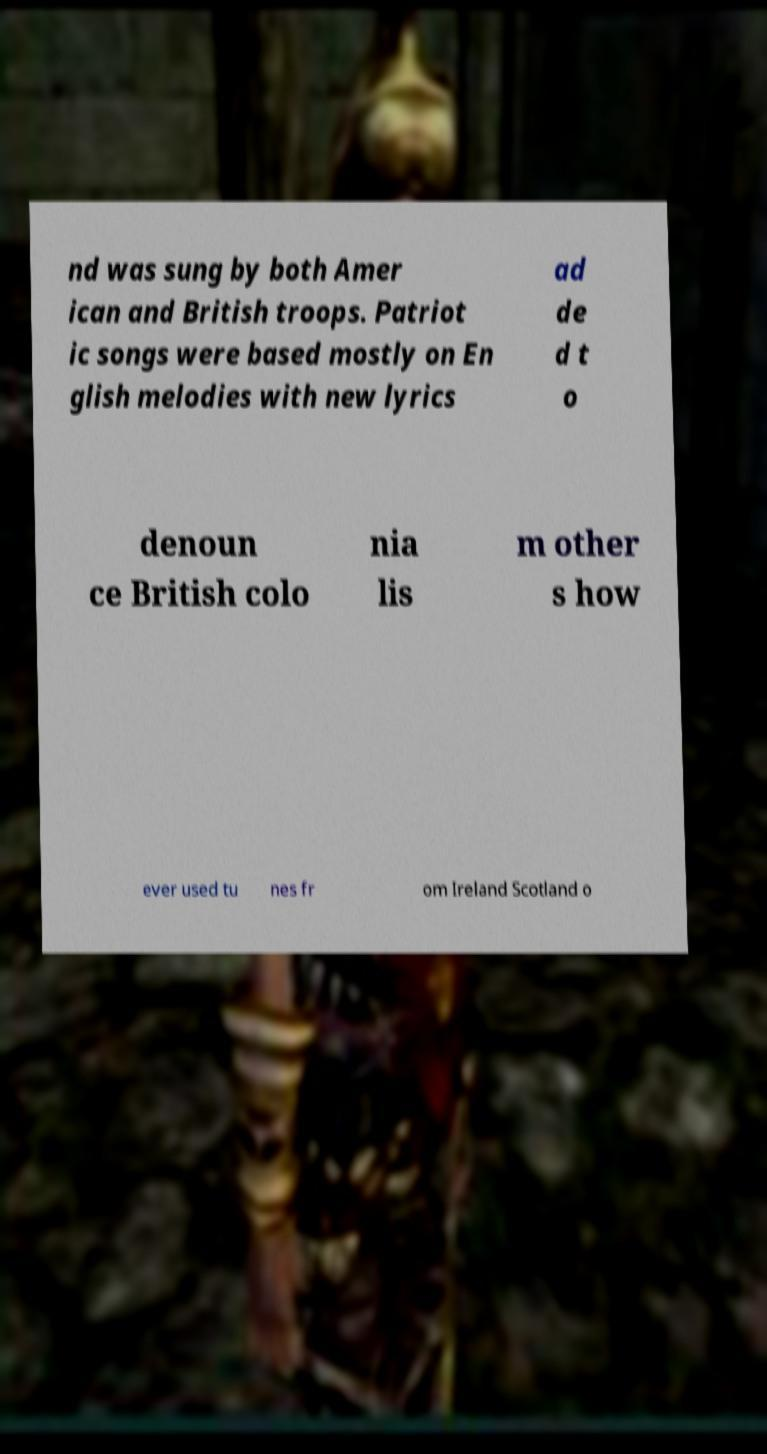Please read and relay the text visible in this image. What does it say? nd was sung by both Amer ican and British troops. Patriot ic songs were based mostly on En glish melodies with new lyrics ad de d t o denoun ce British colo nia lis m other s how ever used tu nes fr om Ireland Scotland o 